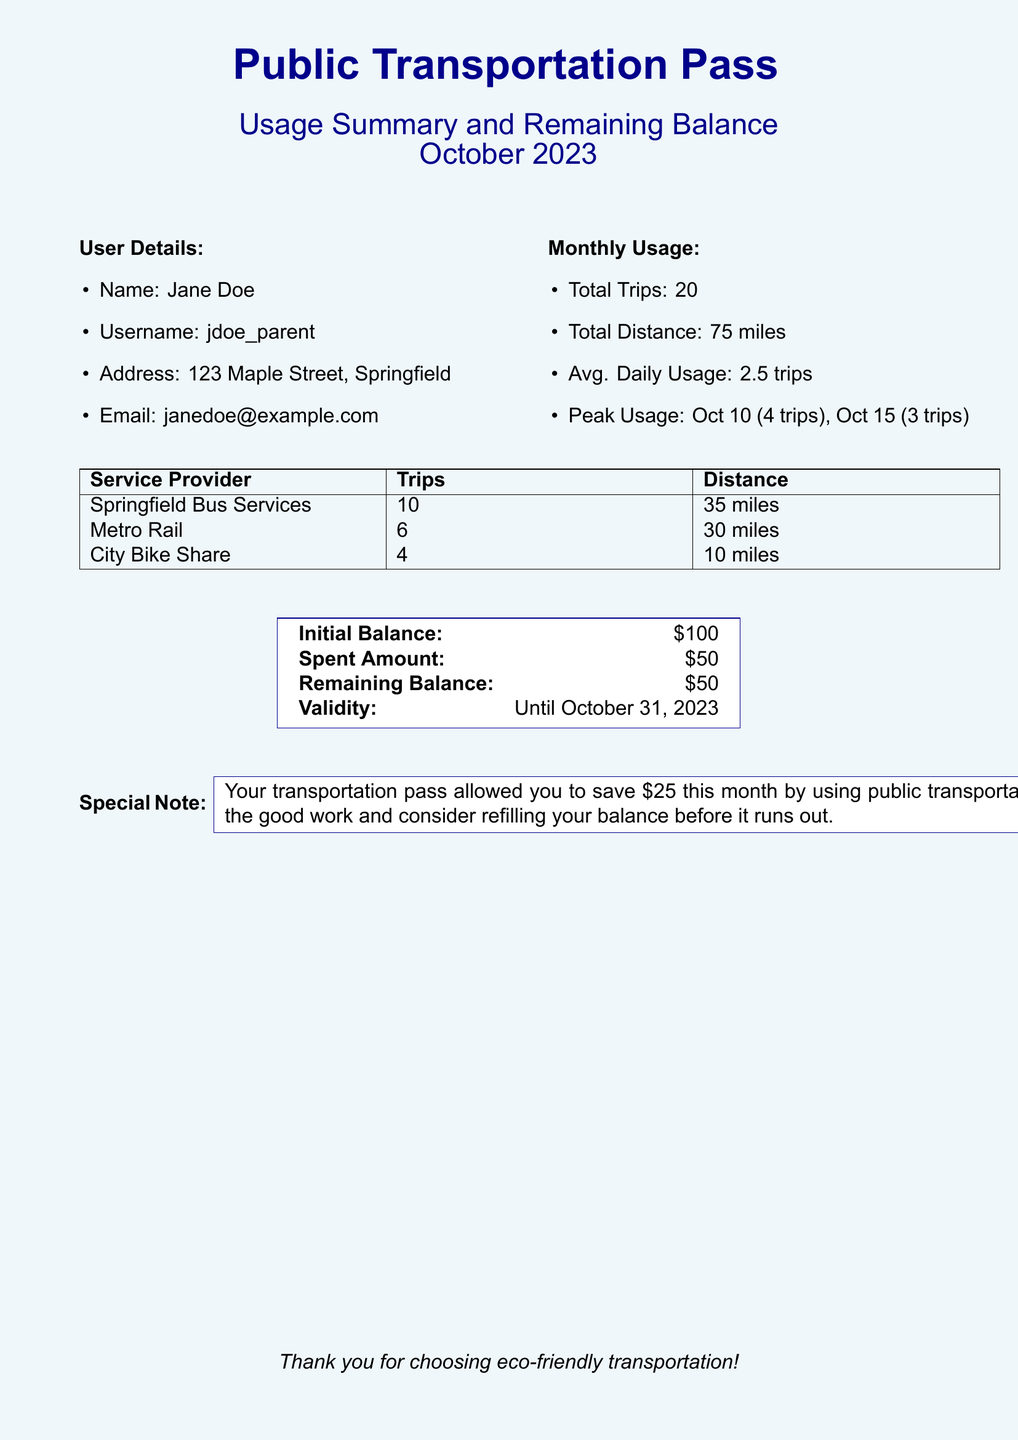What is the name of the user? The document provides the user's details, including their name, which is listed as Jane Doe.
Answer: Jane Doe What is the total number of trips made? The monthly usage section states the total trips made by the user, which is 20.
Answer: 20 What is the average daily usage? The average daily usage is provided in the document, specified as 2.5 trips.
Answer: 2.5 trips How many trips were made using the Springfield Bus Services? The table detailing service provider usage shows that 10 trips were made using Springfield Bus Services.
Answer: 10 What is the remaining balance for the month? The remaining balance is mentioned in the financial summary section, which states a balance of $50.
Answer: $50 On which date was peak usage recorded? The monthly usage section notes peak usage on October 10 and October 15.
Answer: October 10, October 15 What was the initial balance of the transportation pass? The initial balance is specified in the document as $100.
Answer: $100 How much was saved by using public transportation this month? The special note indicates that $25 was saved by using public transportation this month.
Answer: $25 